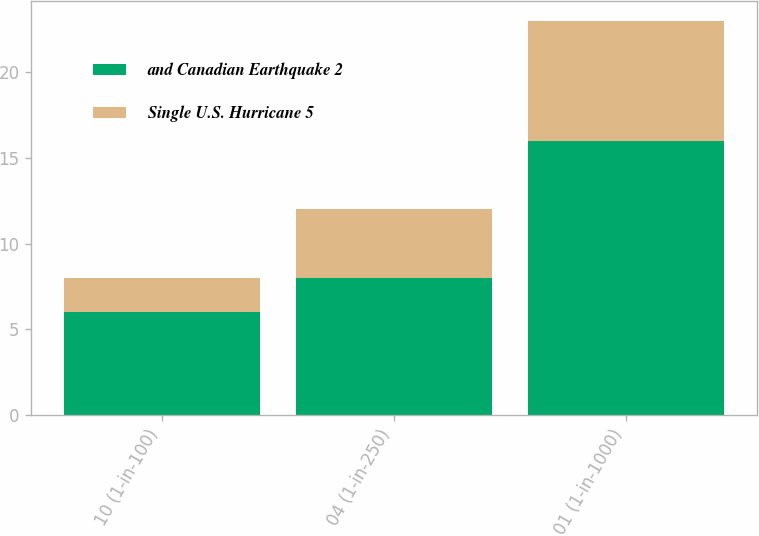Convert chart. <chart><loc_0><loc_0><loc_500><loc_500><stacked_bar_chart><ecel><fcel>10 (1-in-100)<fcel>04 (1-in-250)<fcel>01 (1-in-1000)<nl><fcel>and Canadian Earthquake 2<fcel>6<fcel>8<fcel>16<nl><fcel>Single U.S. Hurricane 5<fcel>2<fcel>4<fcel>7<nl></chart> 